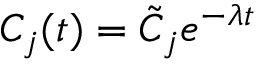<formula> <loc_0><loc_0><loc_500><loc_500>C _ { j } ( t ) = \tilde { C } _ { j } e ^ { - \lambda t }</formula> 